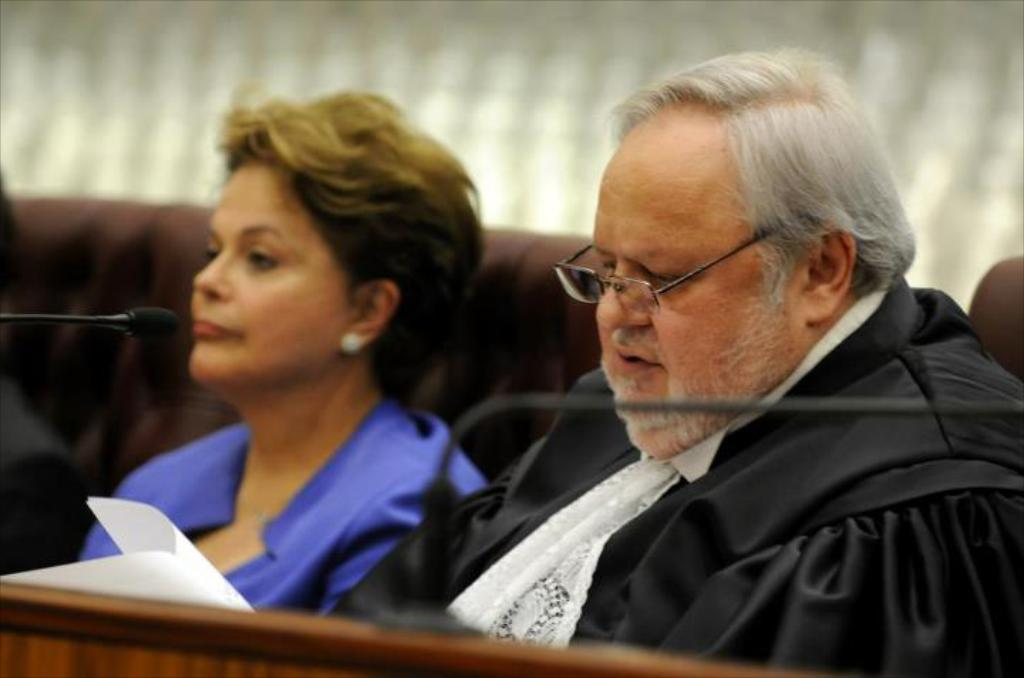What is the man in the image wearing on his face? The man in the image is wearing specs. Who is near the man in the image? There is a lady near the man in the image. What are the positions of the man and the lady in the image? Both the man and the lady are sitting in the image. How would you describe the background of the image? The background of the image is blurred. What objects related to communication can be seen in the image? There are microphones (mics) in the image. What type of written material is present in the image? There are papers in the image. What type of button can be seen on the basketball in the image? There is no basketball present in the image, so there is no button on a basketball to be seen. 